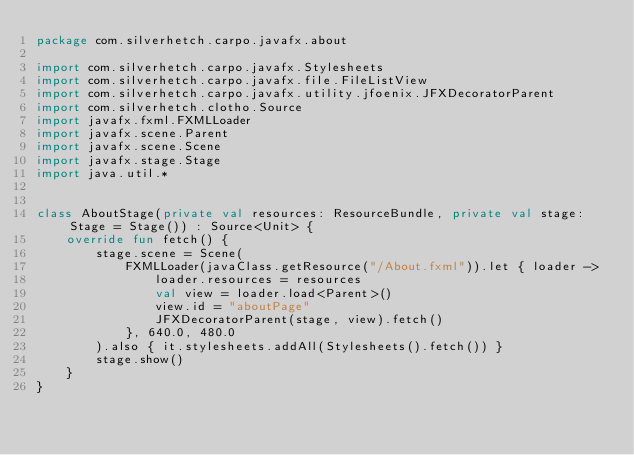Convert code to text. <code><loc_0><loc_0><loc_500><loc_500><_Kotlin_>package com.silverhetch.carpo.javafx.about

import com.silverhetch.carpo.javafx.Stylesheets
import com.silverhetch.carpo.javafx.file.FileListView
import com.silverhetch.carpo.javafx.utility.jfoenix.JFXDecoratorParent
import com.silverhetch.clotho.Source
import javafx.fxml.FXMLLoader
import javafx.scene.Parent
import javafx.scene.Scene
import javafx.stage.Stage
import java.util.*


class AboutStage(private val resources: ResourceBundle, private val stage: Stage = Stage()) : Source<Unit> {
    override fun fetch() {
        stage.scene = Scene(
            FXMLLoader(javaClass.getResource("/About.fxml")).let { loader ->
                loader.resources = resources
                val view = loader.load<Parent>()
                view.id = "aboutPage"
                JFXDecoratorParent(stage, view).fetch()
            }, 640.0, 480.0
        ).also { it.stylesheets.addAll(Stylesheets().fetch()) }
        stage.show()
    }
}</code> 